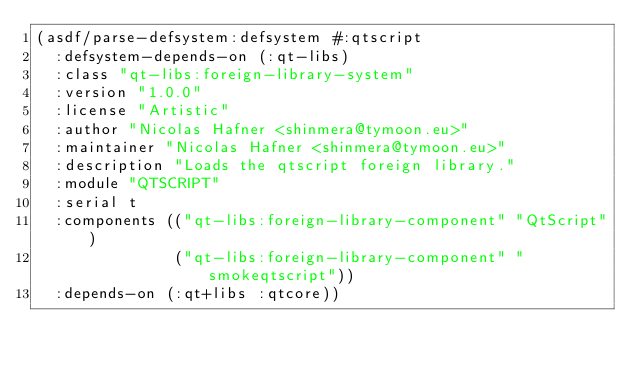<code> <loc_0><loc_0><loc_500><loc_500><_Lisp_>(asdf/parse-defsystem:defsystem #:qtscript
  :defsystem-depends-on (:qt-libs)
  :class "qt-libs:foreign-library-system"
  :version "1.0.0"
  :license "Artistic"
  :author "Nicolas Hafner <shinmera@tymoon.eu>"
  :maintainer "Nicolas Hafner <shinmera@tymoon.eu>"
  :description "Loads the qtscript foreign library."
  :module "QTSCRIPT"
  :serial t
  :components (("qt-libs:foreign-library-component" "QtScript")
               ("qt-libs:foreign-library-component" "smokeqtscript"))
  :depends-on (:qt+libs :qtcore))</code> 